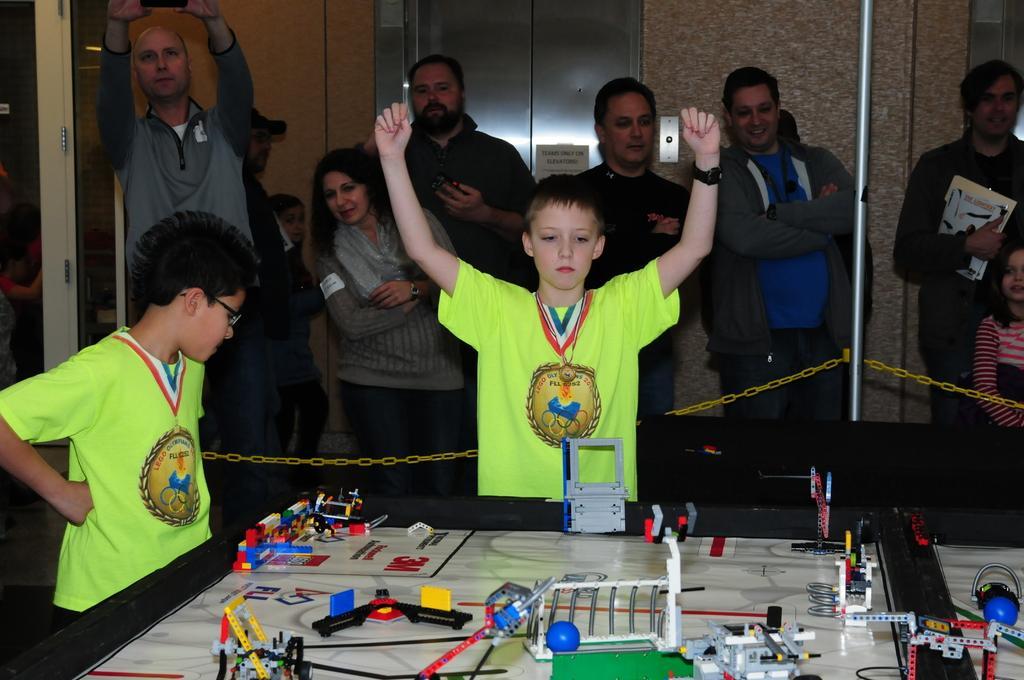Could you give a brief overview of what you see in this image? This picture shows few people standing and we see a man standing and holding camera in his hand and we see women standing and holding books in her hand and we see toys on the table. We see couple of boy standing they wore green color t-shirts and we see a lift door. 